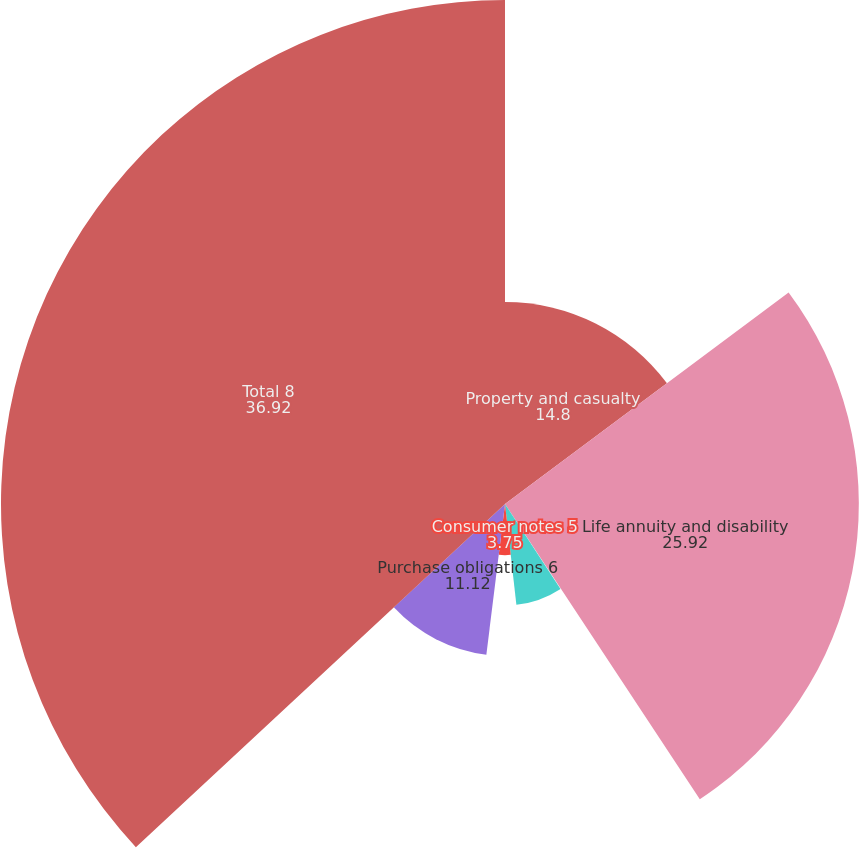<chart> <loc_0><loc_0><loc_500><loc_500><pie_chart><fcel>Property and casualty<fcel>Life annuity and disability<fcel>Operating lease obligations 3<fcel>Long-term debt obligations 4<fcel>Consumer notes 5<fcel>Purchase obligations 6<fcel>Total 8<nl><fcel>14.8%<fcel>25.92%<fcel>0.06%<fcel>7.43%<fcel>3.75%<fcel>11.12%<fcel>36.92%<nl></chart> 